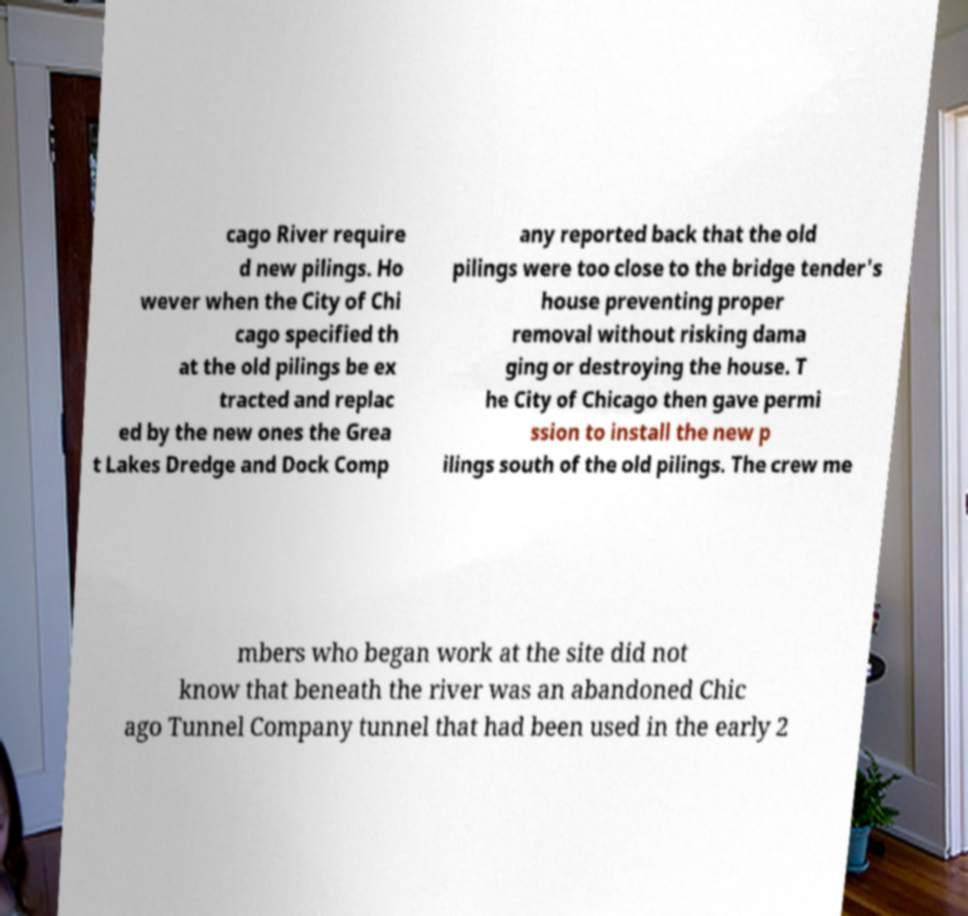There's text embedded in this image that I need extracted. Can you transcribe it verbatim? cago River require d new pilings. Ho wever when the City of Chi cago specified th at the old pilings be ex tracted and replac ed by the new ones the Grea t Lakes Dredge and Dock Comp any reported back that the old pilings were too close to the bridge tender's house preventing proper removal without risking dama ging or destroying the house. T he City of Chicago then gave permi ssion to install the new p ilings south of the old pilings. The crew me mbers who began work at the site did not know that beneath the river was an abandoned Chic ago Tunnel Company tunnel that had been used in the early 2 